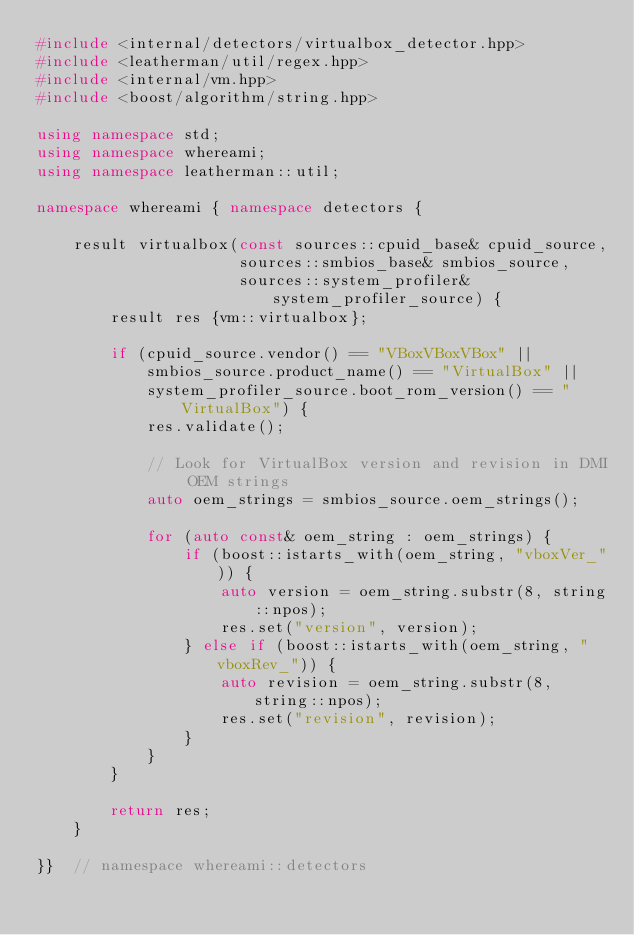Convert code to text. <code><loc_0><loc_0><loc_500><loc_500><_C++_>#include <internal/detectors/virtualbox_detector.hpp>
#include <leatherman/util/regex.hpp>
#include <internal/vm.hpp>
#include <boost/algorithm/string.hpp>

using namespace std;
using namespace whereami;
using namespace leatherman::util;

namespace whereami { namespace detectors {

    result virtualbox(const sources::cpuid_base& cpuid_source,
                      sources::smbios_base& smbios_source,
                      sources::system_profiler& system_profiler_source) {
        result res {vm::virtualbox};

        if (cpuid_source.vendor() == "VBoxVBoxVBox" ||
            smbios_source.product_name() == "VirtualBox" ||
            system_profiler_source.boot_rom_version() == "VirtualBox") {
            res.validate();

            // Look for VirtualBox version and revision in DMI OEM strings
            auto oem_strings = smbios_source.oem_strings();

            for (auto const& oem_string : oem_strings) {
                if (boost::istarts_with(oem_string, "vboxVer_")) {
                    auto version = oem_string.substr(8, string::npos);
                    res.set("version", version);
                } else if (boost::istarts_with(oem_string, "vboxRev_")) {
                    auto revision = oem_string.substr(8, string::npos);
                    res.set("revision", revision);
                }
            }
        }

        return res;
    }

}}  // namespace whereami::detectors
</code> 